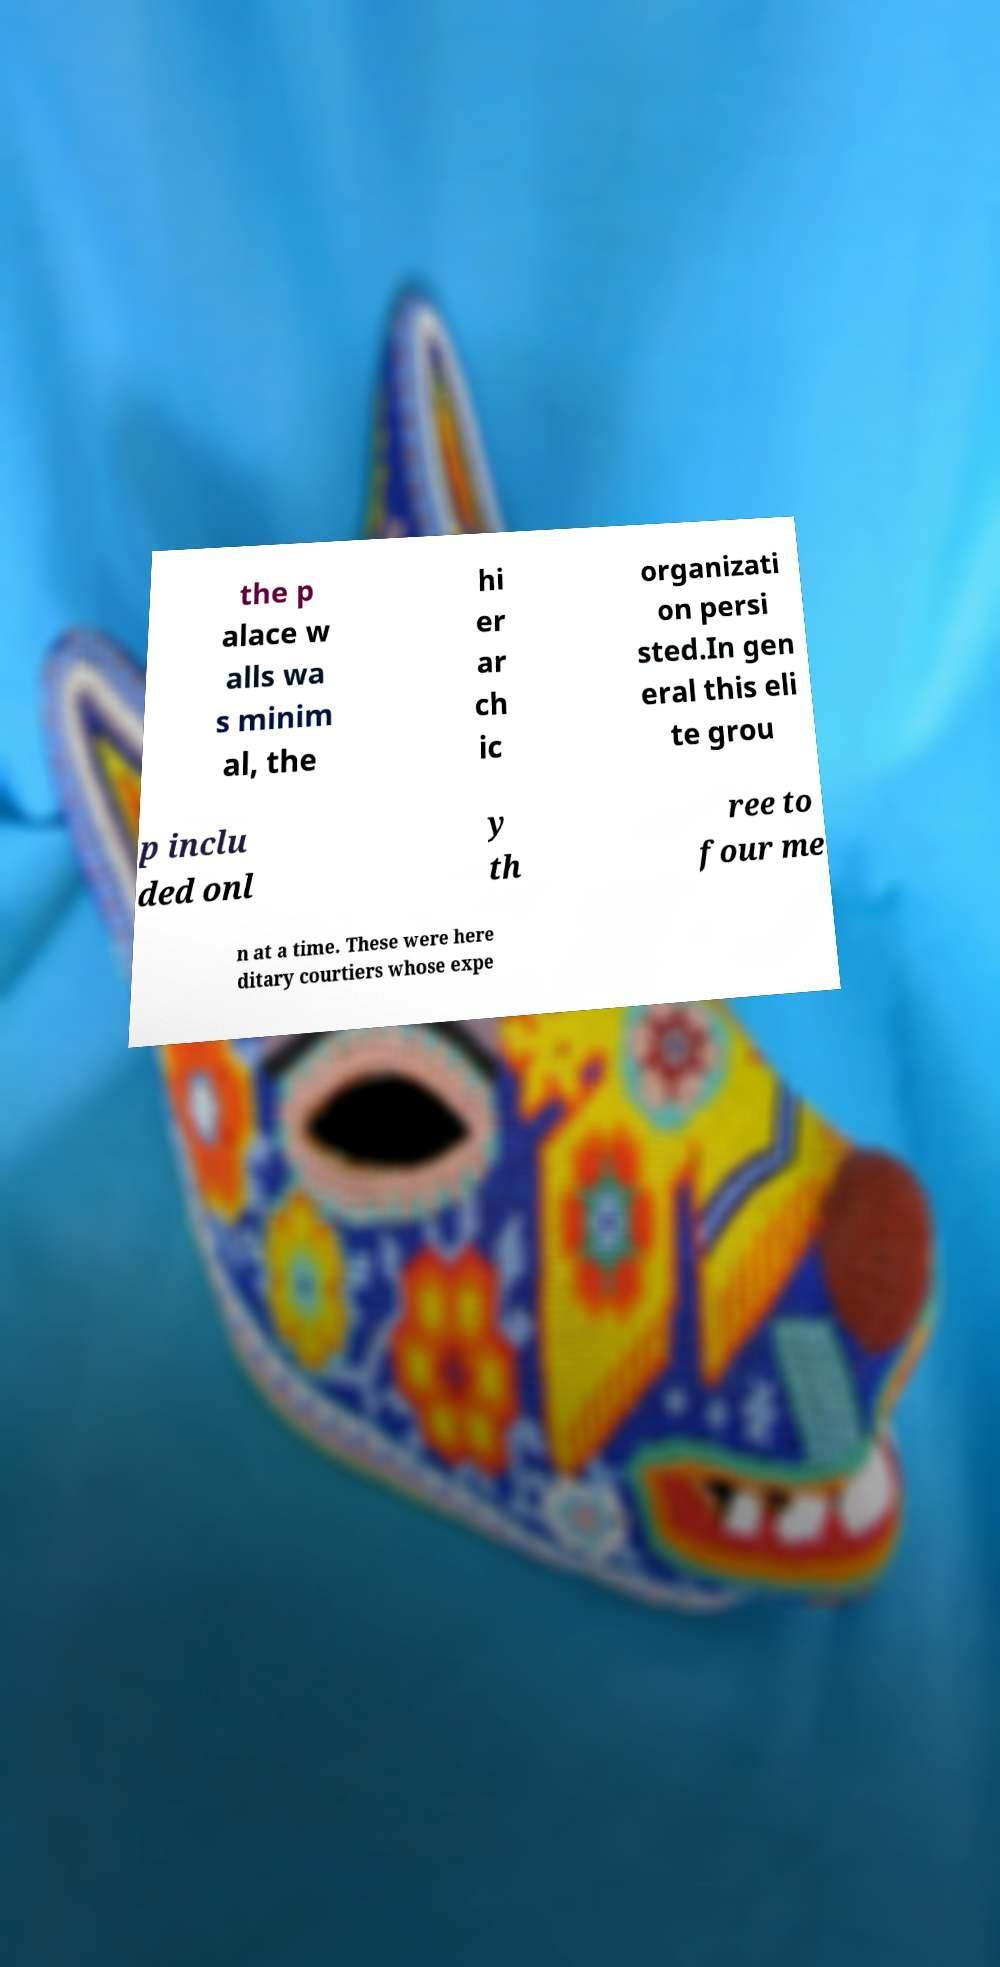What messages or text are displayed in this image? I need them in a readable, typed format. the p alace w alls wa s minim al, the hi er ar ch ic organizati on persi sted.In gen eral this eli te grou p inclu ded onl y th ree to four me n at a time. These were here ditary courtiers whose expe 